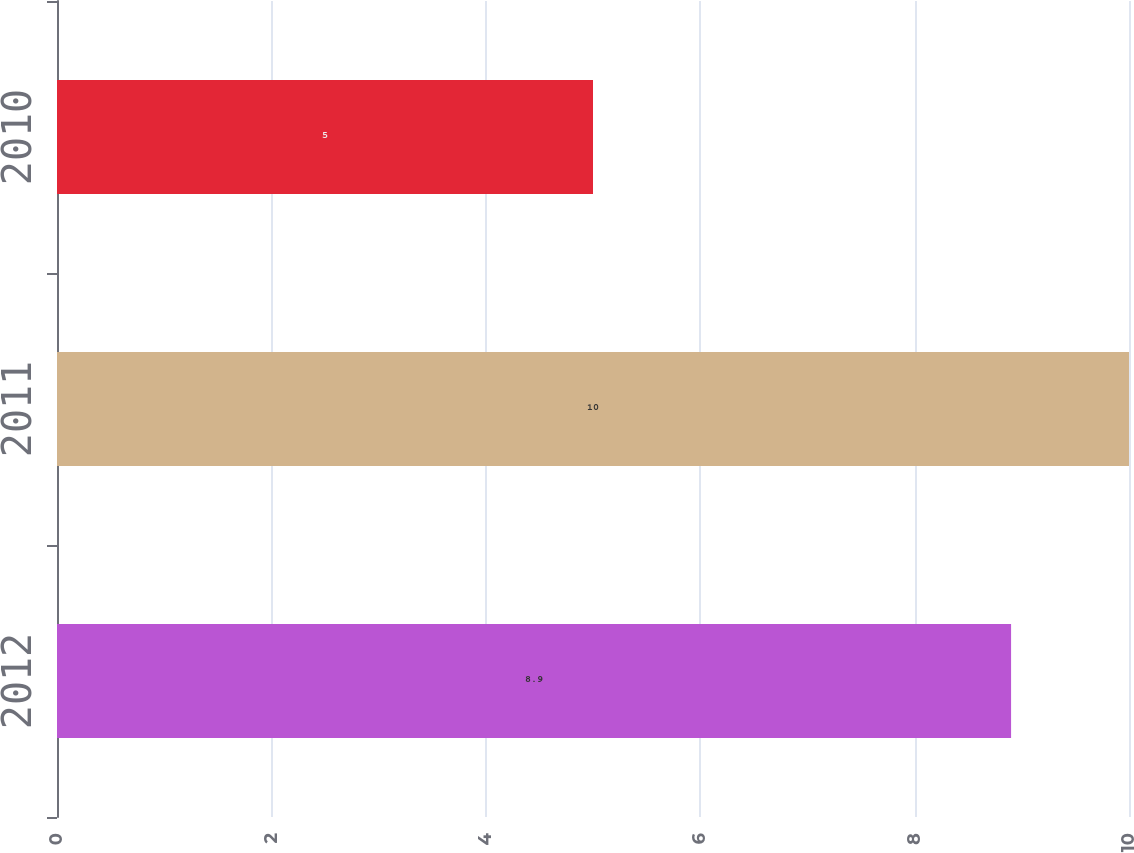Convert chart. <chart><loc_0><loc_0><loc_500><loc_500><bar_chart><fcel>2012<fcel>2011<fcel>2010<nl><fcel>8.9<fcel>10<fcel>5<nl></chart> 